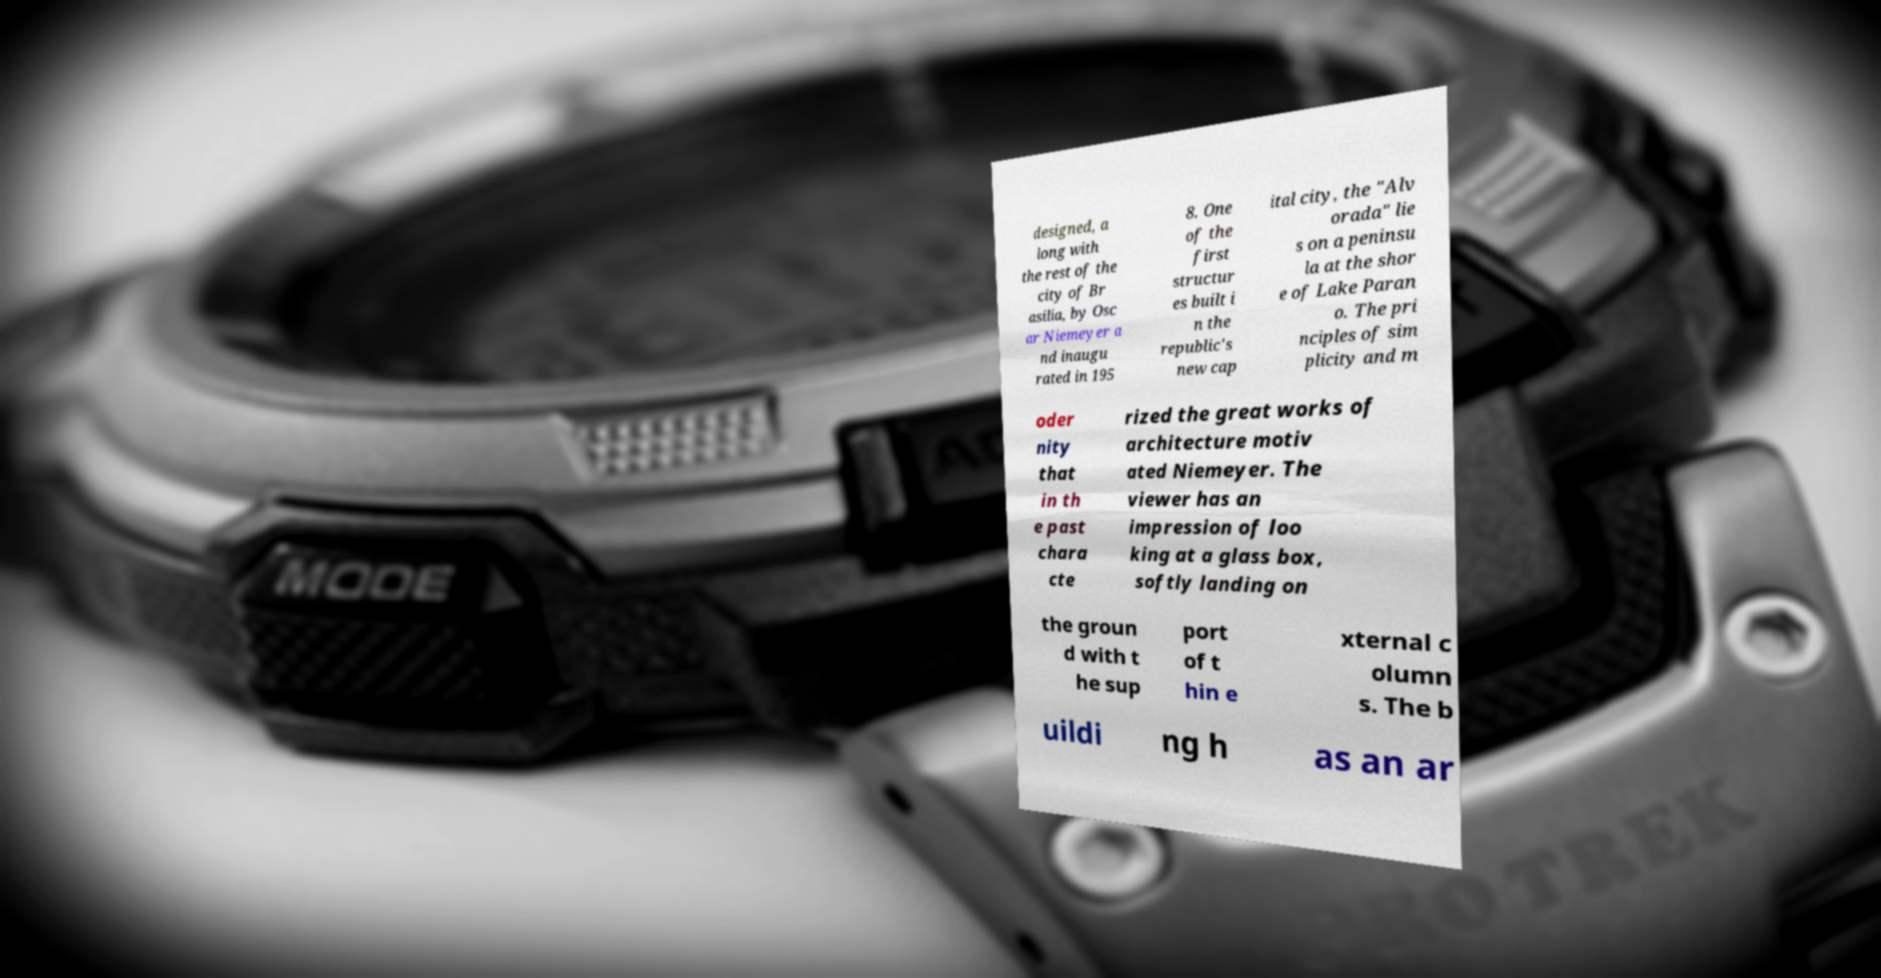There's text embedded in this image that I need extracted. Can you transcribe it verbatim? designed, a long with the rest of the city of Br asilia, by Osc ar Niemeyer a nd inaugu rated in 195 8. One of the first structur es built i n the republic's new cap ital city, the "Alv orada" lie s on a peninsu la at the shor e of Lake Paran o. The pri nciples of sim plicity and m oder nity that in th e past chara cte rized the great works of architecture motiv ated Niemeyer. The viewer has an impression of loo king at a glass box, softly landing on the groun d with t he sup port of t hin e xternal c olumn s. The b uildi ng h as an ar 